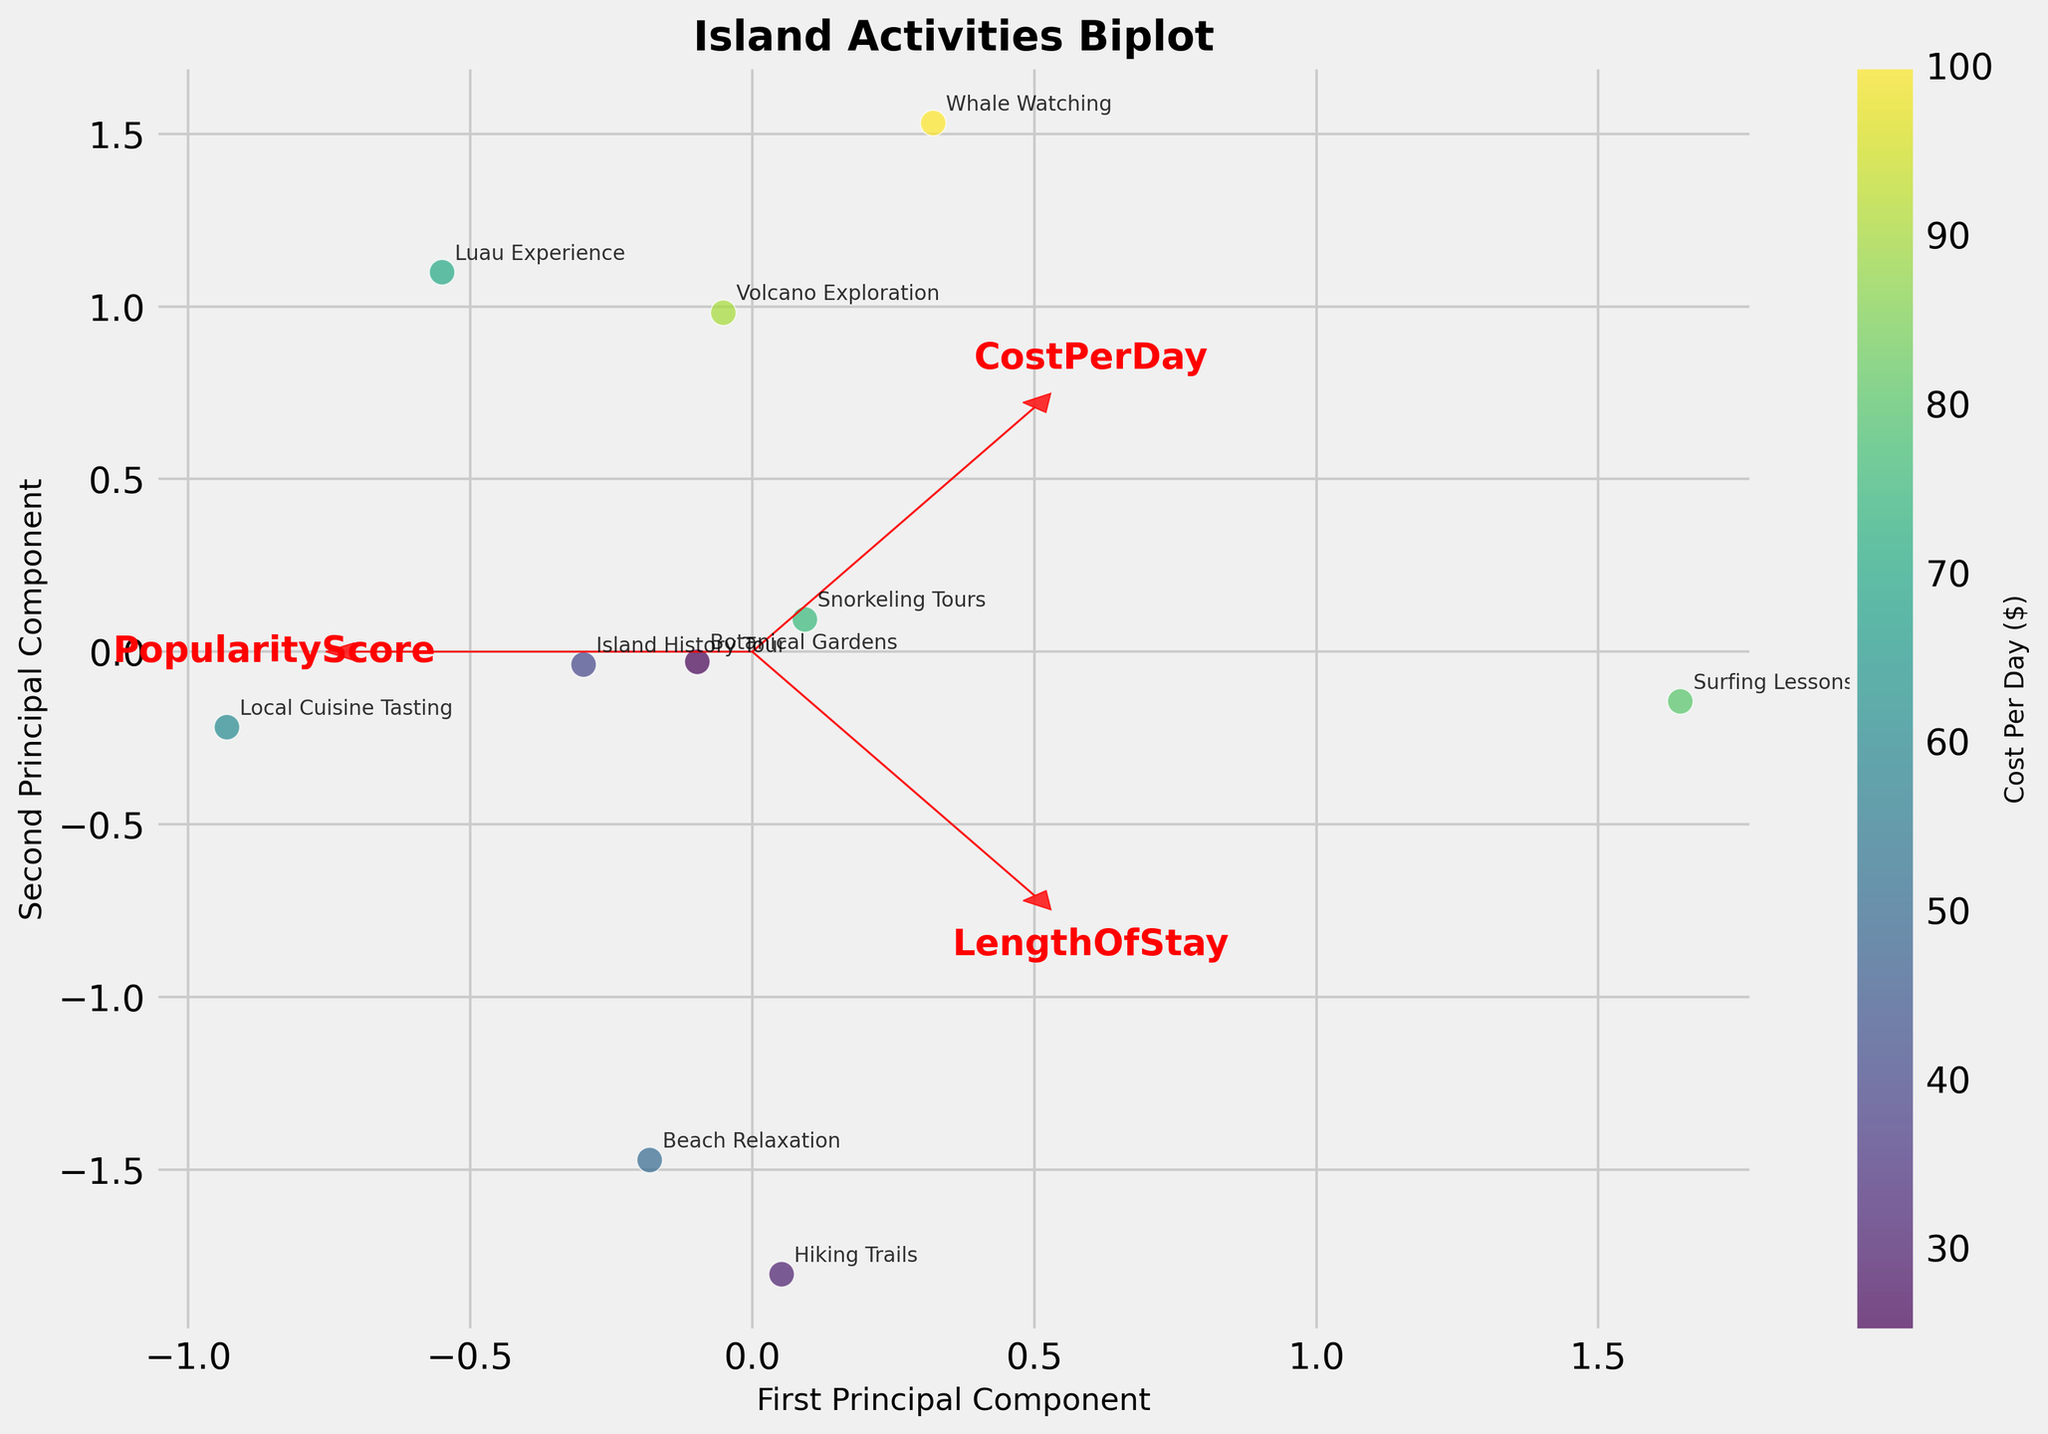What is the title of the plot? The title of a plot is typically found at the top of the figure. Here, it reads "Island Activities Biplot".
Answer: Island Activities Biplot How many principal components are shown in the plot? The plot displays two axes, each representing a principal component. The x-axis is labeled "First Principal Component" and the y-axis is labeled "Second Principal Component".
Answer: Two Which activity has the highest cost per day and where is it located in the plot? Whale Watching has the highest cost per day ($100) as indicated by the color gradient. It is located towards the upper right of the plot.
Answer: Whale Watching, upper right What is the general relationship between LengthOfStay and PopularityScore based on their vectors? The vectors for LengthOfStay and PopularityScore are pointing in similar directions, indicating a positive correlation between them. This means that activities with higher LengthOfStay tend to be more popular.
Answer: Positive correlation Which activity has the shortest length of stay and where is it positioned in the plot? Botanical Gardens has the shortest length of stay (1.8 days). It is positioned towards the lower left of the plot.
Answer: Botanical Gardens, lower left Which three activities have the closest projection on the second principal component? By observing the vertical positions of the points, the activities Hiking Trails, Local Cuisine Tasting, and Snorkeling Tours have projections very close to each other along the second principal component.
Answer: Hiking Trails, Local Cuisine Tasting, Snorkeling Tours Identify the activities with LengthOfStay above 4 days and specify their positions in the plot. The activities with LengthOfStay above 4 days are Beach Relaxation, Hiking Trails, and Surfing Lessons. Beach Relaxation is in the middle right, Hiking Trails in the middle, and Surfing Lessons is lower middle.
Answer: Beach Relaxation, Hiking Trails, Surfing Lessons What can you infer about the cost per day for activities located in the lower left quadrant of the plot? Activities in the lower left quadrant, such as Botanical Gardens and Island History Tour, generally have lower costs per day, as indicated by the lighter color in the plot.
Answer: Generally lower cost per day Which activity is the closest to the origin and what does this imply? Island History Tour is closest to the origin, implying it has average LengthOfStay, PopularityScore, and CostPerDay relative to the other activities.
Answer: Island History Tour What can be inferred about the relationship between CostPerDay and PopularityScore based on the biplot vectors? The vectors for CostPerDay and PopularityScore are somewhat aligned but not perfectly, suggesting a moderate positive correlation. Activities with higher costs tend to be somewhat more popular.
Answer: Moderate positive correlation 